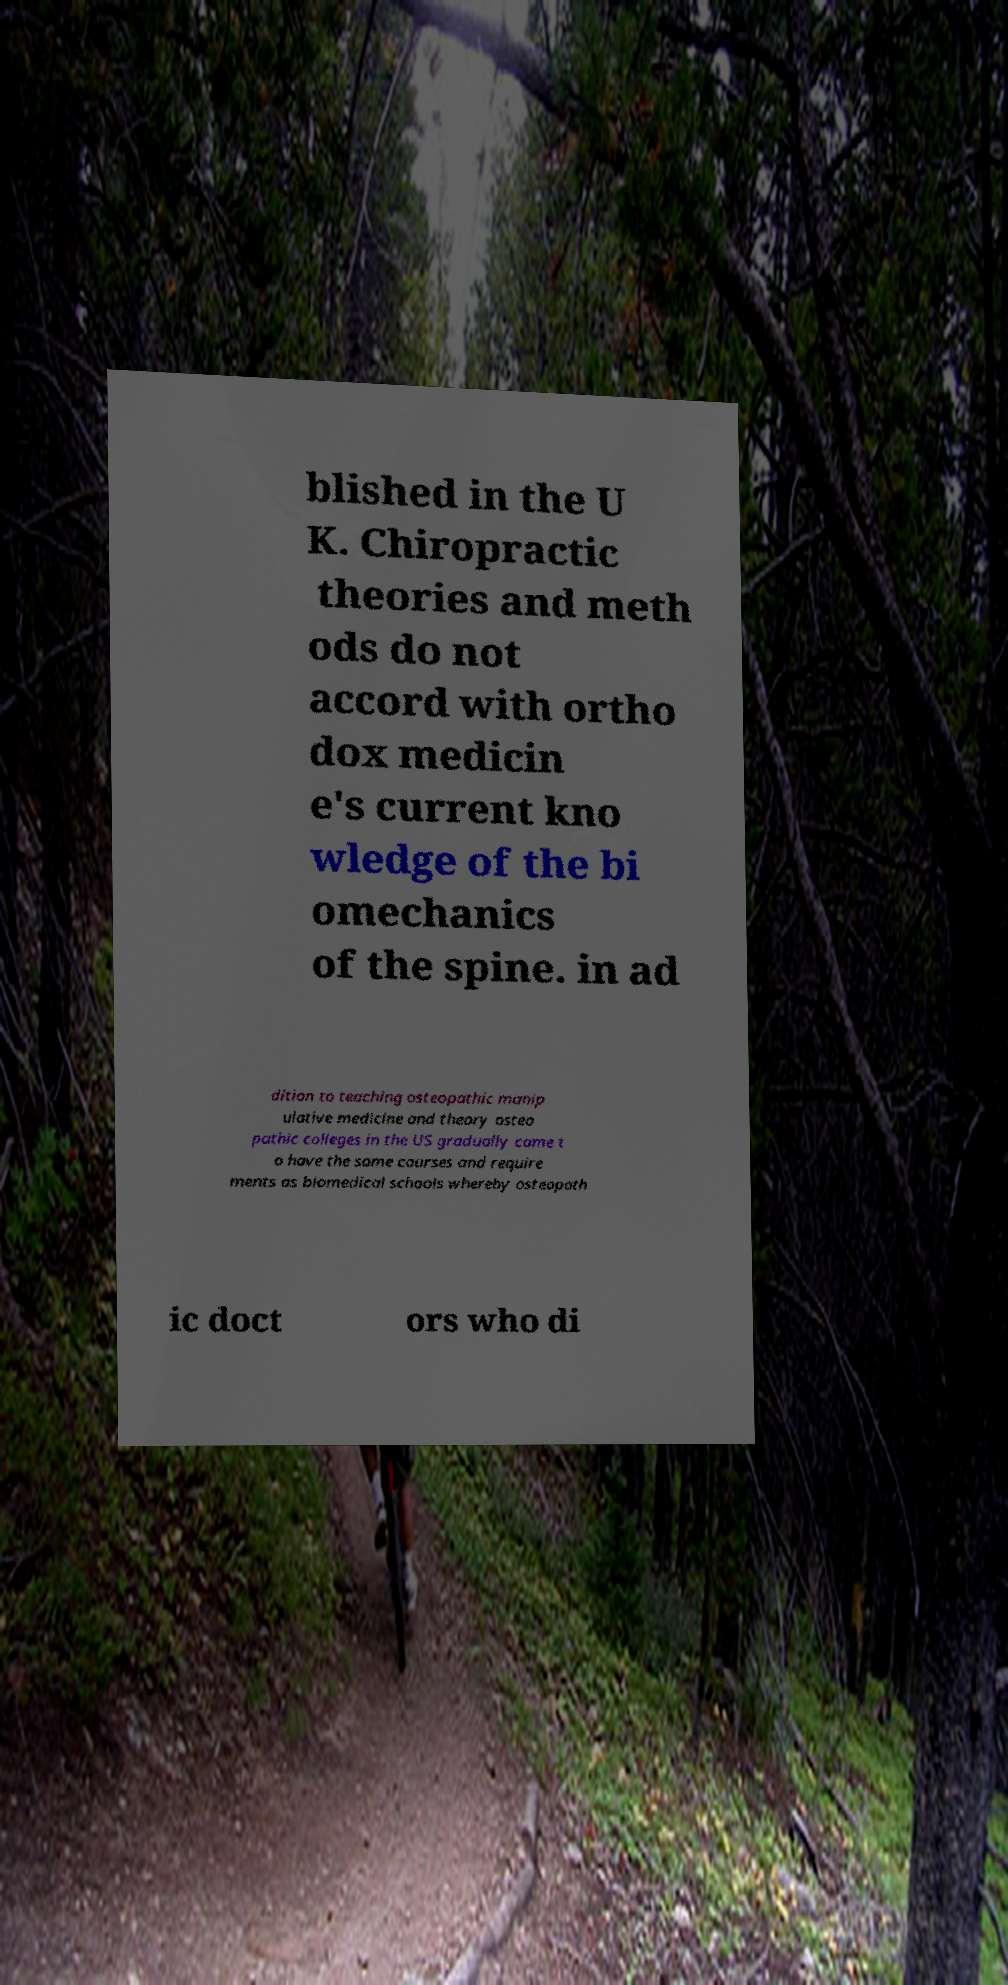There's text embedded in this image that I need extracted. Can you transcribe it verbatim? blished in the U K. Chiropractic theories and meth ods do not accord with ortho dox medicin e's current kno wledge of the bi omechanics of the spine. in ad dition to teaching osteopathic manip ulative medicine and theory osteo pathic colleges in the US gradually came t o have the same courses and require ments as biomedical schools whereby osteopath ic doct ors who di 